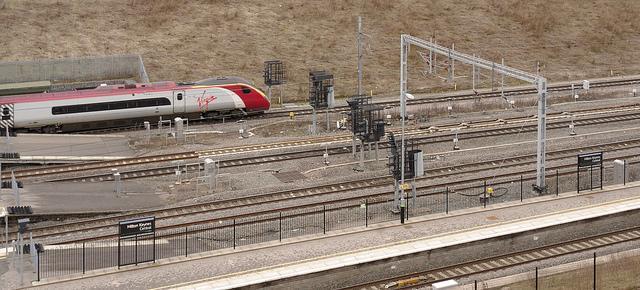How many giraffe are standing in the field?
Give a very brief answer. 0. 